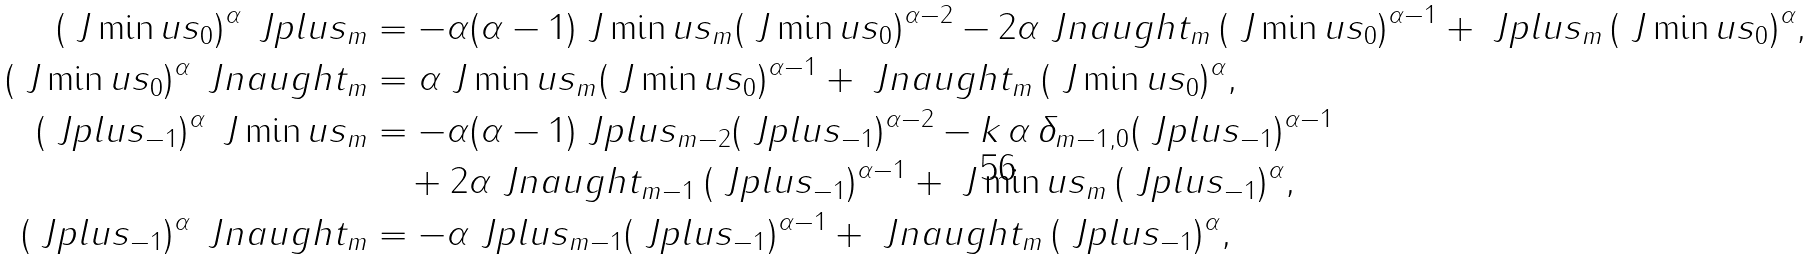<formula> <loc_0><loc_0><loc_500><loc_500>( \ J \min u s _ { 0 } ) ^ { \alpha } \, \ J p l u s _ { m } & = - \alpha ( \alpha - 1 ) \ J \min u s _ { m } ( \ J \min u s _ { 0 } ) ^ { \alpha - 2 } - 2 \alpha \ J n a u g h t _ { m } \, ( \ J \min u s _ { 0 } ) ^ { \alpha - 1 } + \ J p l u s _ { m } \, ( \ J \min u s _ { 0 } ) ^ { \alpha } , \\ ( \ J \min u s _ { 0 } ) ^ { \alpha } \, \ J n a u g h t _ { m } & = \alpha \ J \min u s _ { m } ( \ J \min u s _ { 0 } ) ^ { \alpha - 1 } + \ J n a u g h t _ { m } \, ( \ J \min u s _ { 0 } ) ^ { \alpha } , \\ ( \ J p l u s _ { - 1 } ) ^ { \alpha } \, \ J \min u s _ { m } & = - \alpha ( \alpha - 1 ) \ J p l u s _ { m - 2 } ( \ J p l u s _ { - 1 } ) ^ { \alpha - 2 } - k \, \alpha \, \delta _ { m - 1 , 0 } ( \ J p l u s _ { - 1 } ) ^ { \alpha - 1 } \\ & \quad + 2 \alpha \ J n a u g h t _ { m - 1 } \, ( \ J p l u s _ { - 1 } ) ^ { \alpha - 1 } + \ J \min u s _ { m } \, ( \ J p l u s _ { - 1 } ) ^ { \alpha } , \\ ( \ J p l u s _ { - 1 } ) ^ { \alpha } \, \ J n a u g h t _ { m } & = - \alpha \ J p l u s _ { m - 1 } ( \ J p l u s _ { - 1 } ) ^ { \alpha - 1 } + \ J n a u g h t _ { m } \, ( \ J p l u s _ { - 1 } ) ^ { \alpha } ,</formula> 